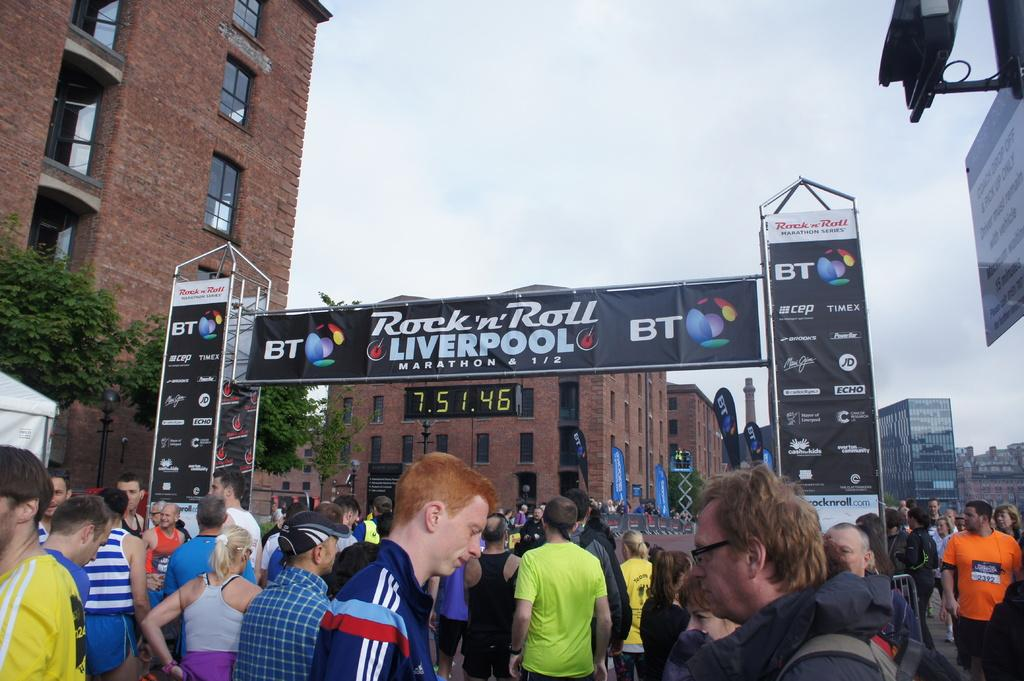<image>
Share a concise interpretation of the image provided. The time clock at the Liverpool marathon says it's been almost eight hours so far. 